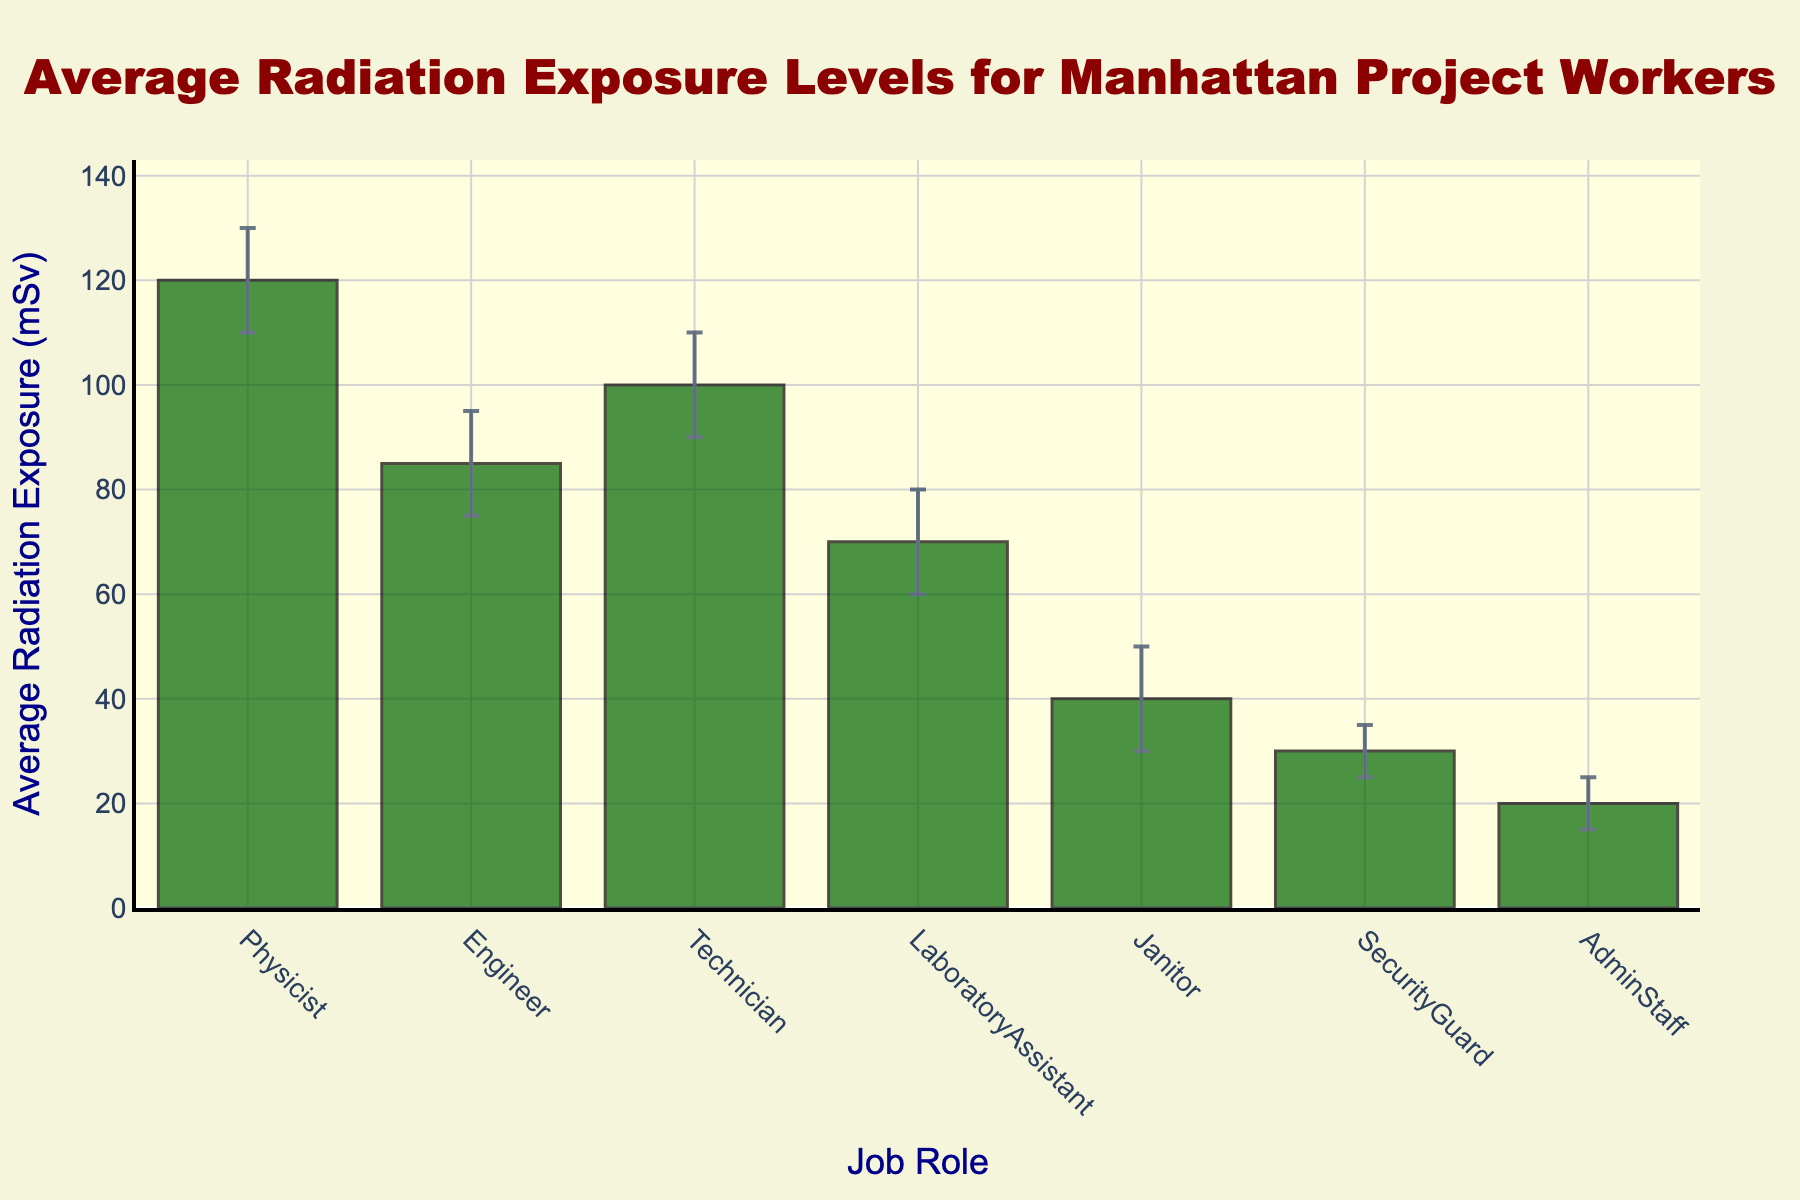What's the title of the figure? The title is typically displayed at the top of the figure and can be directly read.
Answer: Average Radiation Exposure Levels for Manhattan Project Workers Which job role has the highest average radiation exposure level? The highest bar in the chart represents the job role with the highest exposure. Observe that the Physicist bar is the tallest.
Answer: Physicist Which job role has the lowest average radiation exposure level? The shortest bar in the chart represents the job role with the lowest exposure. Observe that the AdminStaff bar is the shortest.
Answer: AdminStaff What is the average radiation exposure level for technicians? Locate the bar labeled Technician and read the corresponding y-value.
Answer: 100 mSv What range of radiation exposure levels does the Engineer role have, considering the confidence intervals? Look at the error bars extending from the average value for the Engineer. The LowerCI is 75 mSv, and the UpperCI is 95 mSv.
Answer: 75-95 mSv Which job role has a larger range for its confidence interval, Physicist or Janitor? Calculate the range for each role by subtracting the LowerCI from the UpperCI. For Physicist, it's 130 - 110 = 20 mSv. For Janitor, it's 50 - 30 = 20 mSv. Both ranges are equal.
Answer: Both have the same range How much higher is the average radiation exposure for Engineers compared to Janitors? Subtract the Janitor's average exposure from the Engineer's average exposure: 85 mSv - 40 mSv.
Answer: 45 mSv Which job role's confidence interval overlaps with the average radiation exposure of Technicians? Look at the error bars for each role and see if they include 100 mSv. Both Engineer (75-95 mSv) and Physicist (110-130 mSv) do not include 100 mSv, while LaboratoryAssistant's range of 60-80 mSv also doesn't include 100 mSv. The overlapping roles with exposure around 100 mSv are not present.
Answer: None Between the SecurityGuard and AdminStaff, which role has a narrower confidence interval range? Calculate each range by subtracting the LowerCI from the UpperCI: SecurityGuard (35-25=10 mSv) and AdminStaff (25-15=10 mSv). Both have the same range.
Answer: Both have the same range How does the average exposure for LaboratoryAssistants compare to the total average exposure of Physicists and Engineers? Calculate the total average of Physicists and Engineers: (120 mSv + 85 mSv) / 2 = 102.5 mSv. Compare this to the average exposure of LaboratoryAssistants, which is 70 mSv.
Answer: LaboratoryAssistants have lower exposure than the average of Physicists and Engineers 